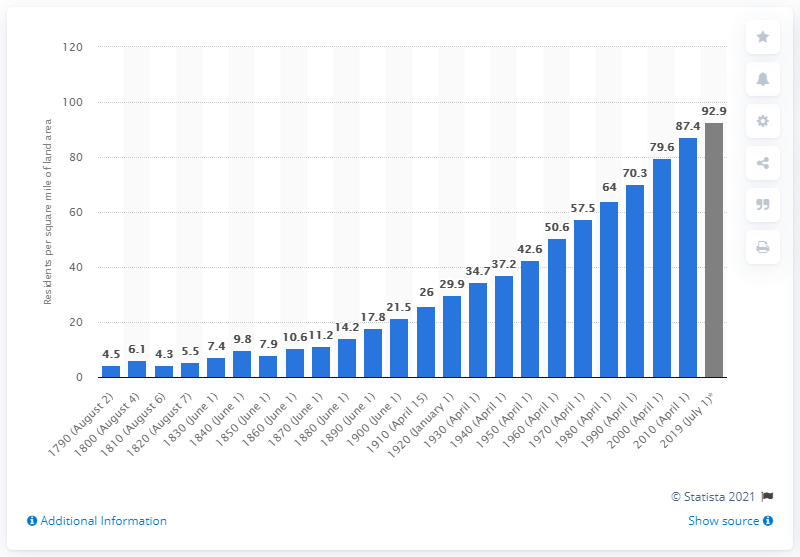Identify some key points in this picture. The estimated population density of land in 2019 was 92.9 people per square mile. 